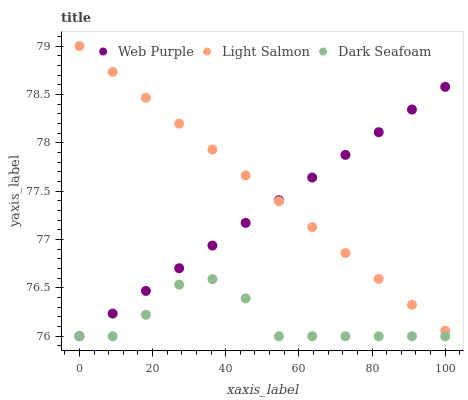Does Dark Seafoam have the minimum area under the curve?
Answer yes or no. Yes. Does Light Salmon have the maximum area under the curve?
Answer yes or no. Yes. Does Light Salmon have the minimum area under the curve?
Answer yes or no. No. Does Dark Seafoam have the maximum area under the curve?
Answer yes or no. No. Is Web Purple the smoothest?
Answer yes or no. Yes. Is Dark Seafoam the roughest?
Answer yes or no. Yes. Is Light Salmon the smoothest?
Answer yes or no. No. Is Light Salmon the roughest?
Answer yes or no. No. Does Web Purple have the lowest value?
Answer yes or no. Yes. Does Light Salmon have the lowest value?
Answer yes or no. No. Does Light Salmon have the highest value?
Answer yes or no. Yes. Does Dark Seafoam have the highest value?
Answer yes or no. No. Is Dark Seafoam less than Light Salmon?
Answer yes or no. Yes. Is Light Salmon greater than Dark Seafoam?
Answer yes or no. Yes. Does Web Purple intersect Dark Seafoam?
Answer yes or no. Yes. Is Web Purple less than Dark Seafoam?
Answer yes or no. No. Is Web Purple greater than Dark Seafoam?
Answer yes or no. No. Does Dark Seafoam intersect Light Salmon?
Answer yes or no. No. 